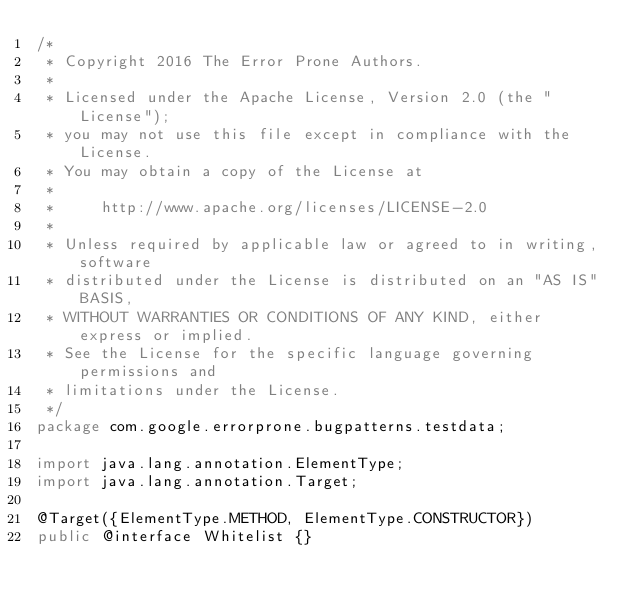Convert code to text. <code><loc_0><loc_0><loc_500><loc_500><_Java_>/*
 * Copyright 2016 The Error Prone Authors.
 *
 * Licensed under the Apache License, Version 2.0 (the "License");
 * you may not use this file except in compliance with the License.
 * You may obtain a copy of the License at
 *
 *     http://www.apache.org/licenses/LICENSE-2.0
 *
 * Unless required by applicable law or agreed to in writing, software
 * distributed under the License is distributed on an "AS IS" BASIS,
 * WITHOUT WARRANTIES OR CONDITIONS OF ANY KIND, either express or implied.
 * See the License for the specific language governing permissions and
 * limitations under the License.
 */
package com.google.errorprone.bugpatterns.testdata;

import java.lang.annotation.ElementType;
import java.lang.annotation.Target;

@Target({ElementType.METHOD, ElementType.CONSTRUCTOR})
public @interface Whitelist {}
</code> 